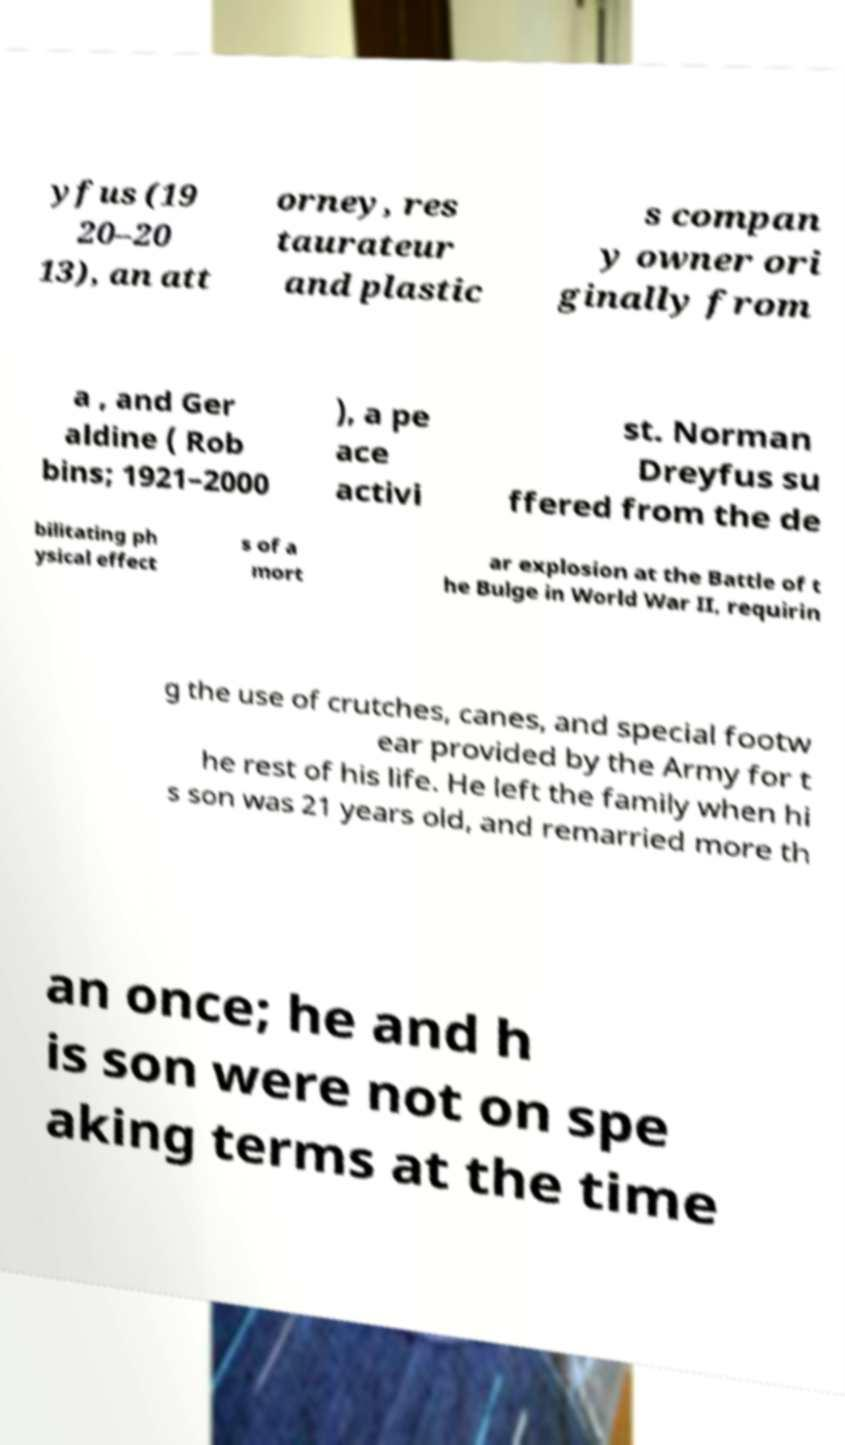Please identify and transcribe the text found in this image. yfus (19 20–20 13), an att orney, res taurateur and plastic s compan y owner ori ginally from a , and Ger aldine ( Rob bins; 1921–2000 ), a pe ace activi st. Norman Dreyfus su ffered from the de bilitating ph ysical effect s of a mort ar explosion at the Battle of t he Bulge in World War II, requirin g the use of crutches, canes, and special footw ear provided by the Army for t he rest of his life. He left the family when hi s son was 21 years old, and remarried more th an once; he and h is son were not on spe aking terms at the time 